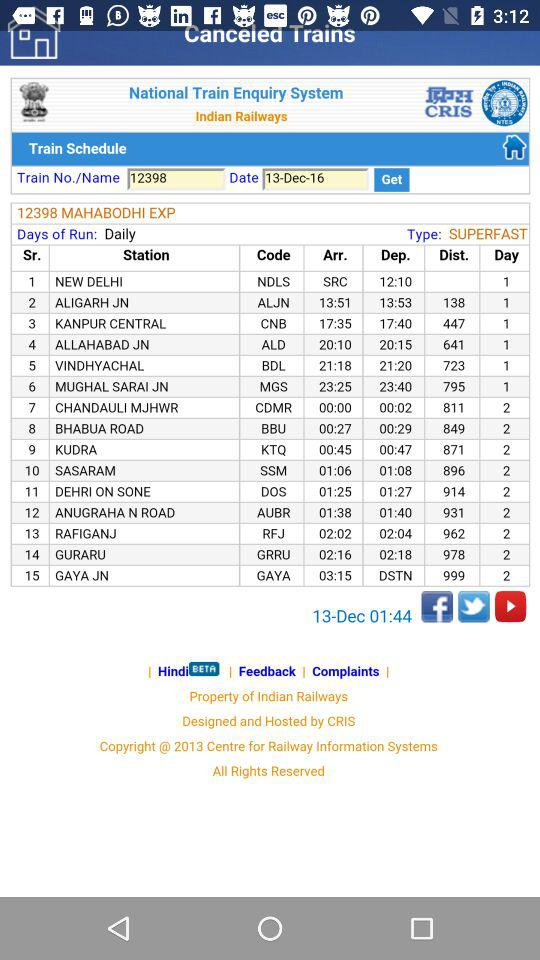At what time was the information last updated? The information was updated at 01:44. 